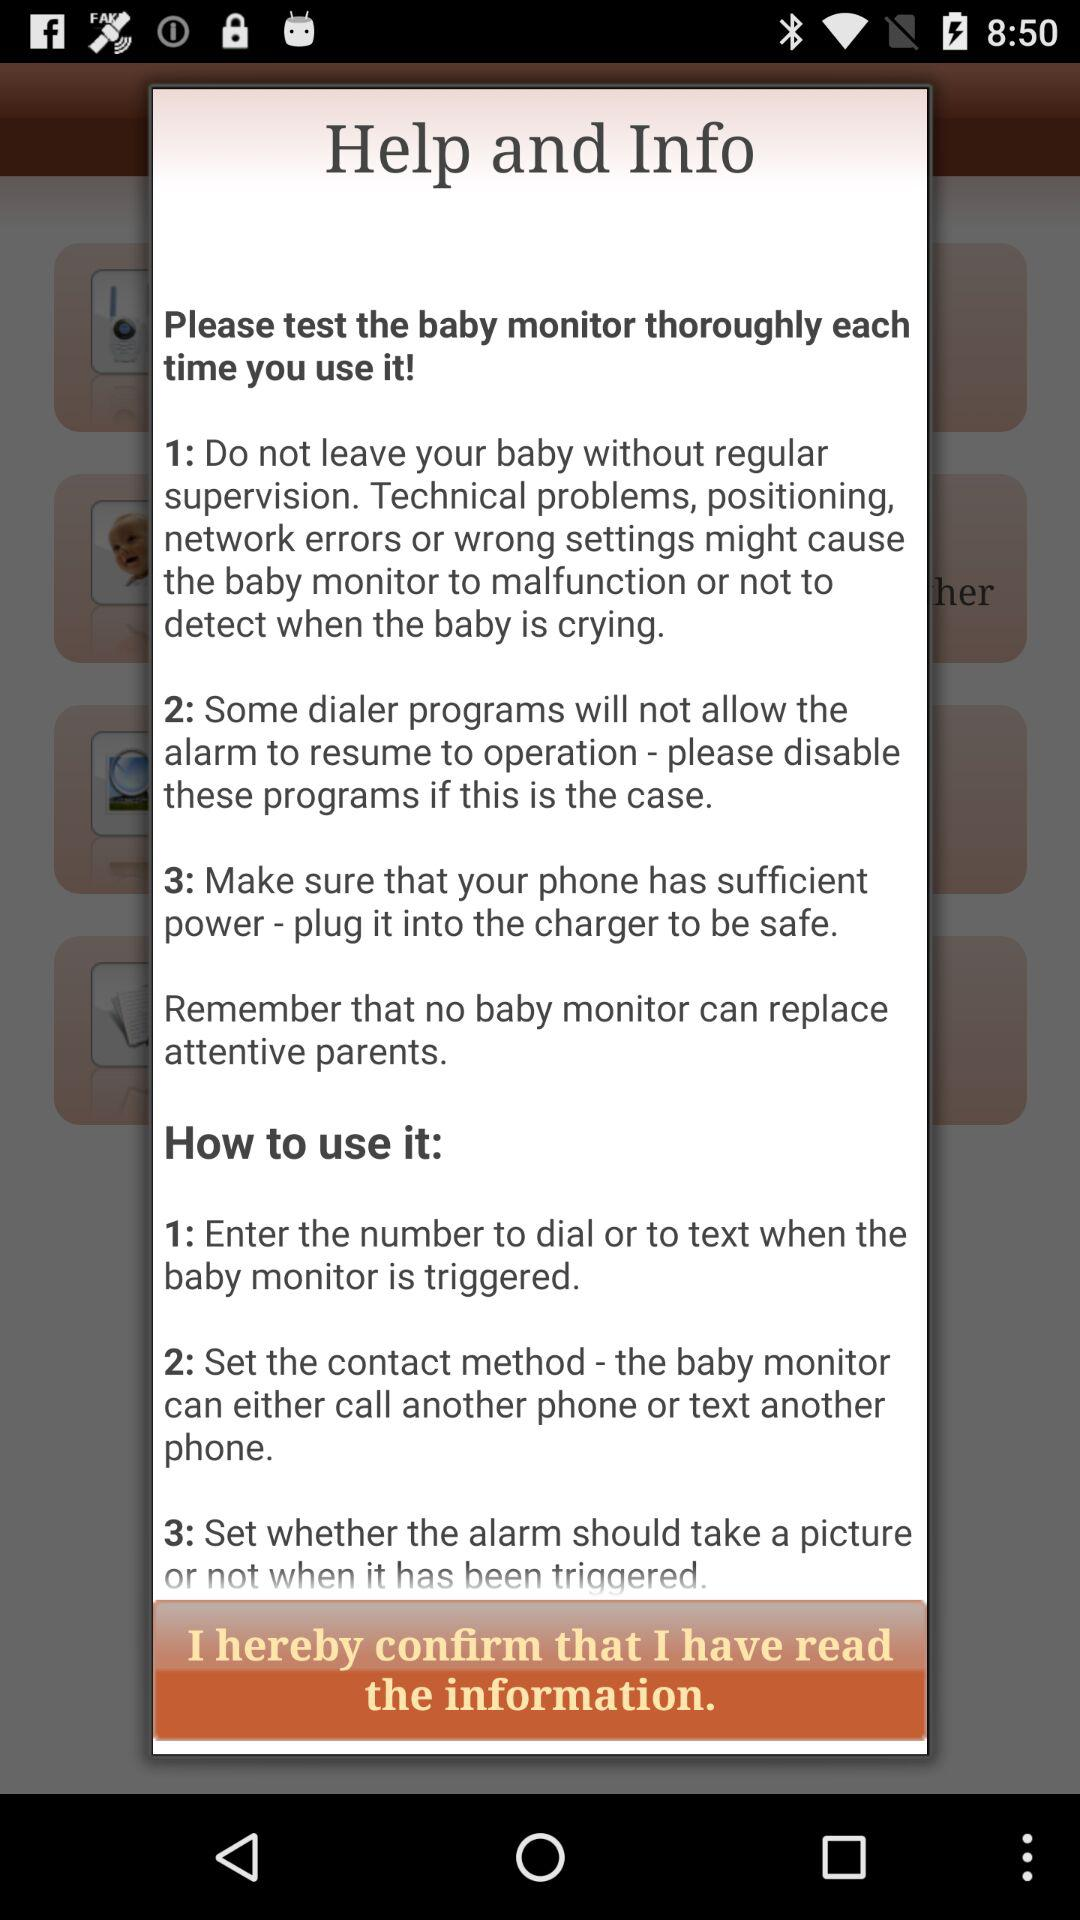How many steps are there in the instructions?
Answer the question using a single word or phrase. 3 